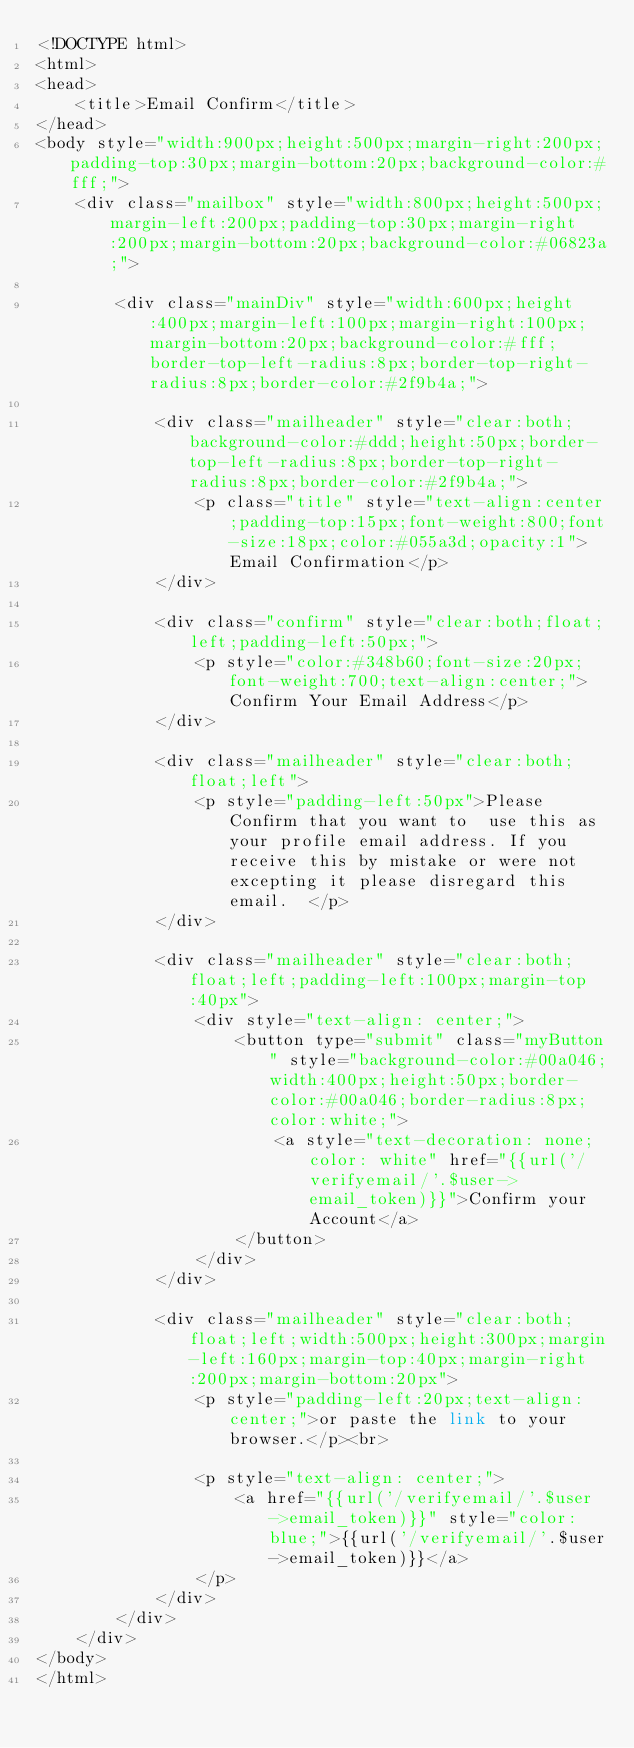<code> <loc_0><loc_0><loc_500><loc_500><_PHP_><!DOCTYPE html>
<html>
<head>
    <title>Email Confirm</title>
</head>
<body style="width:900px;height:500px;margin-right:200px;padding-top:30px;margin-bottom:20px;background-color:#fff;">
    <div class="mailbox" style="width:800px;height:500px;margin-left:200px;padding-top:30px;margin-right:200px;margin-bottom:20px;background-color:#06823a;">
    
        <div class="mainDiv" style="width:600px;height:400px;margin-left:100px;margin-right:100px;margin-bottom:20px;background-color:#fff;border-top-left-radius:8px;border-top-right-radius:8px;border-color:#2f9b4a;">

            <div class="mailheader" style="clear:both;background-color:#ddd;height:50px;border-top-left-radius:8px;border-top-right-radius:8px;border-color:#2f9b4a;">
                <p class="title" style="text-align:center;padding-top:15px;font-weight:800;font-size:18px;color:#055a3d;opacity:1">Email Confirmation</p>
            </div>

            <div class="confirm" style="clear:both;float;left;padding-left:50px;">
                <p style="color:#348b60;font-size:20px;font-weight:700;text-align:center;">Confirm Your Email Address</p>
            </div>

            <div class="mailheader" style="clear:both;float;left">
                <p style="padding-left:50px">Please Confirm that you want to  use this as your profile email address. If you receive this by mistake or were not excepting it please disregard this email.  </p>
            </div>

            <div class="mailheader" style="clear:both;float;left;padding-left:100px;margin-top:40px">
                <div style="text-align: center;">
                    <button type="submit" class="myButton" style="background-color:#00a046;width:400px;height:50px;border-color:#00a046;border-radius:8px;color:white;">
                        <a style="text-decoration: none;color: white" href="{{url('/verifyemail/'.$user->email_token)}}">Confirm your Account</a>
                    </button>
                </div>
            </div>

            <div class="mailheader" style="clear:both;float;left;width:500px;height:300px;margin-left:160px;margin-top:40px;margin-right:200px;margin-bottom:20px">
                <p style="padding-left:20px;text-align:center;">or paste the link to your browser.</p><br>
                
                <p style="text-align: center;">
                    <a href="{{url('/verifyemail/'.$user->email_token)}}" style="color:blue;">{{url('/verifyemail/'.$user->email_token)}}</a>
                </p>
            </div>
        </div>
    </div>
</body>
</html>

</code> 